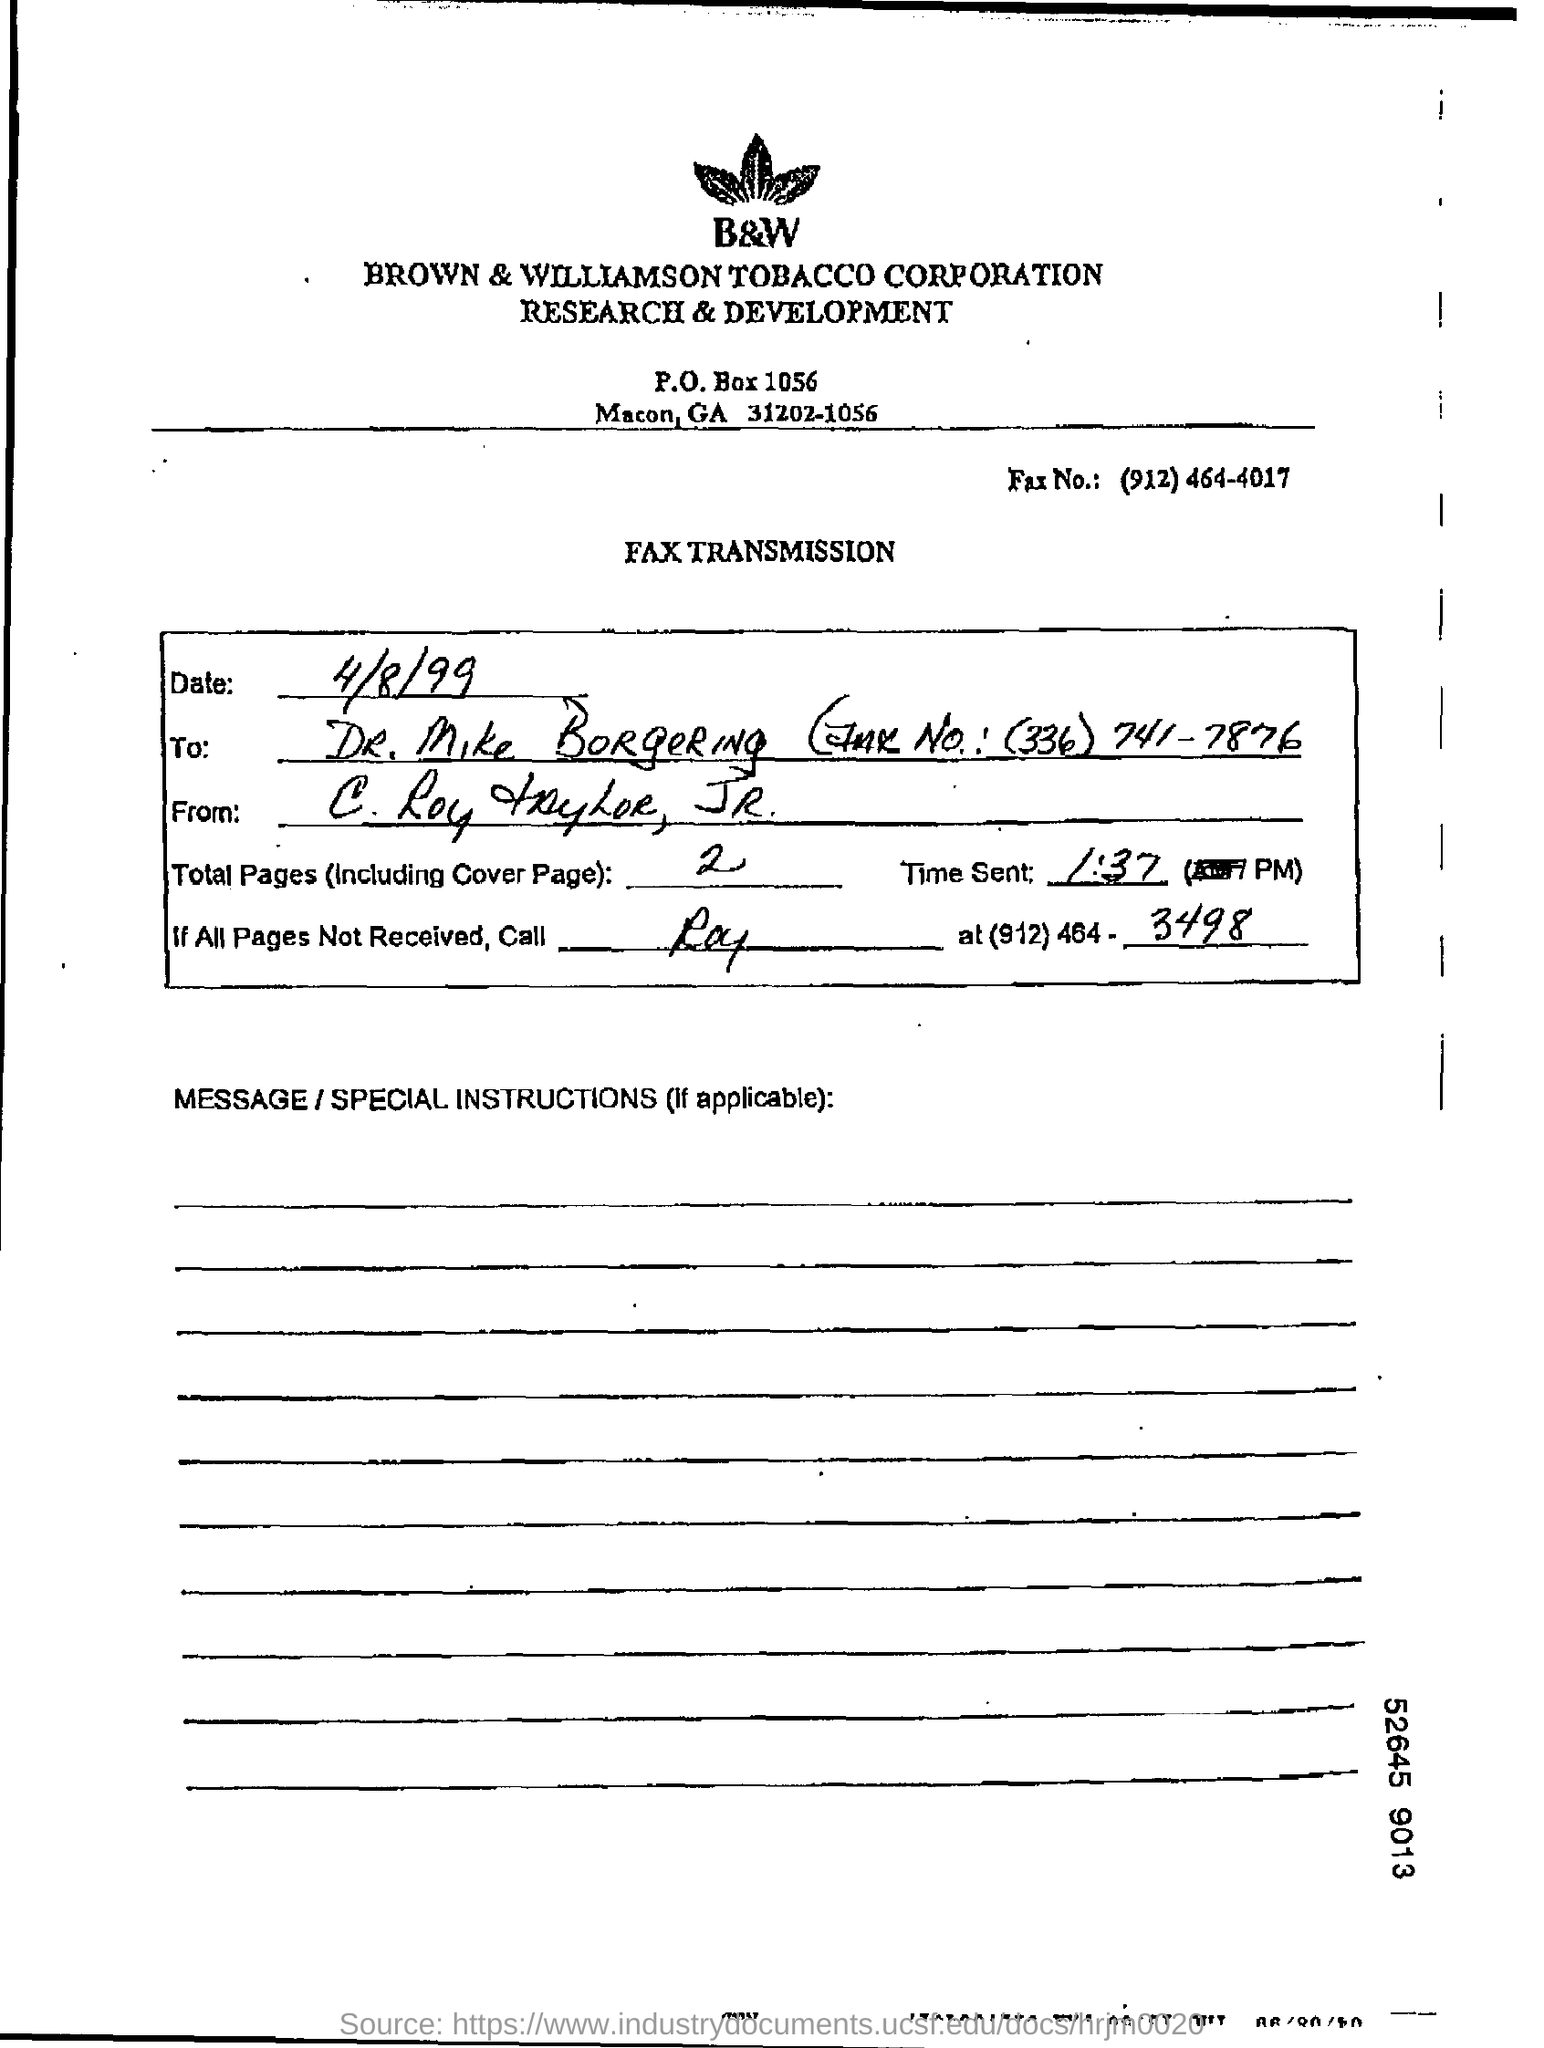Specify some key components in this picture. The transmission in question is a FAX transmission. The p.o. box number is 1056. The number of fax is (912)464-4017. 